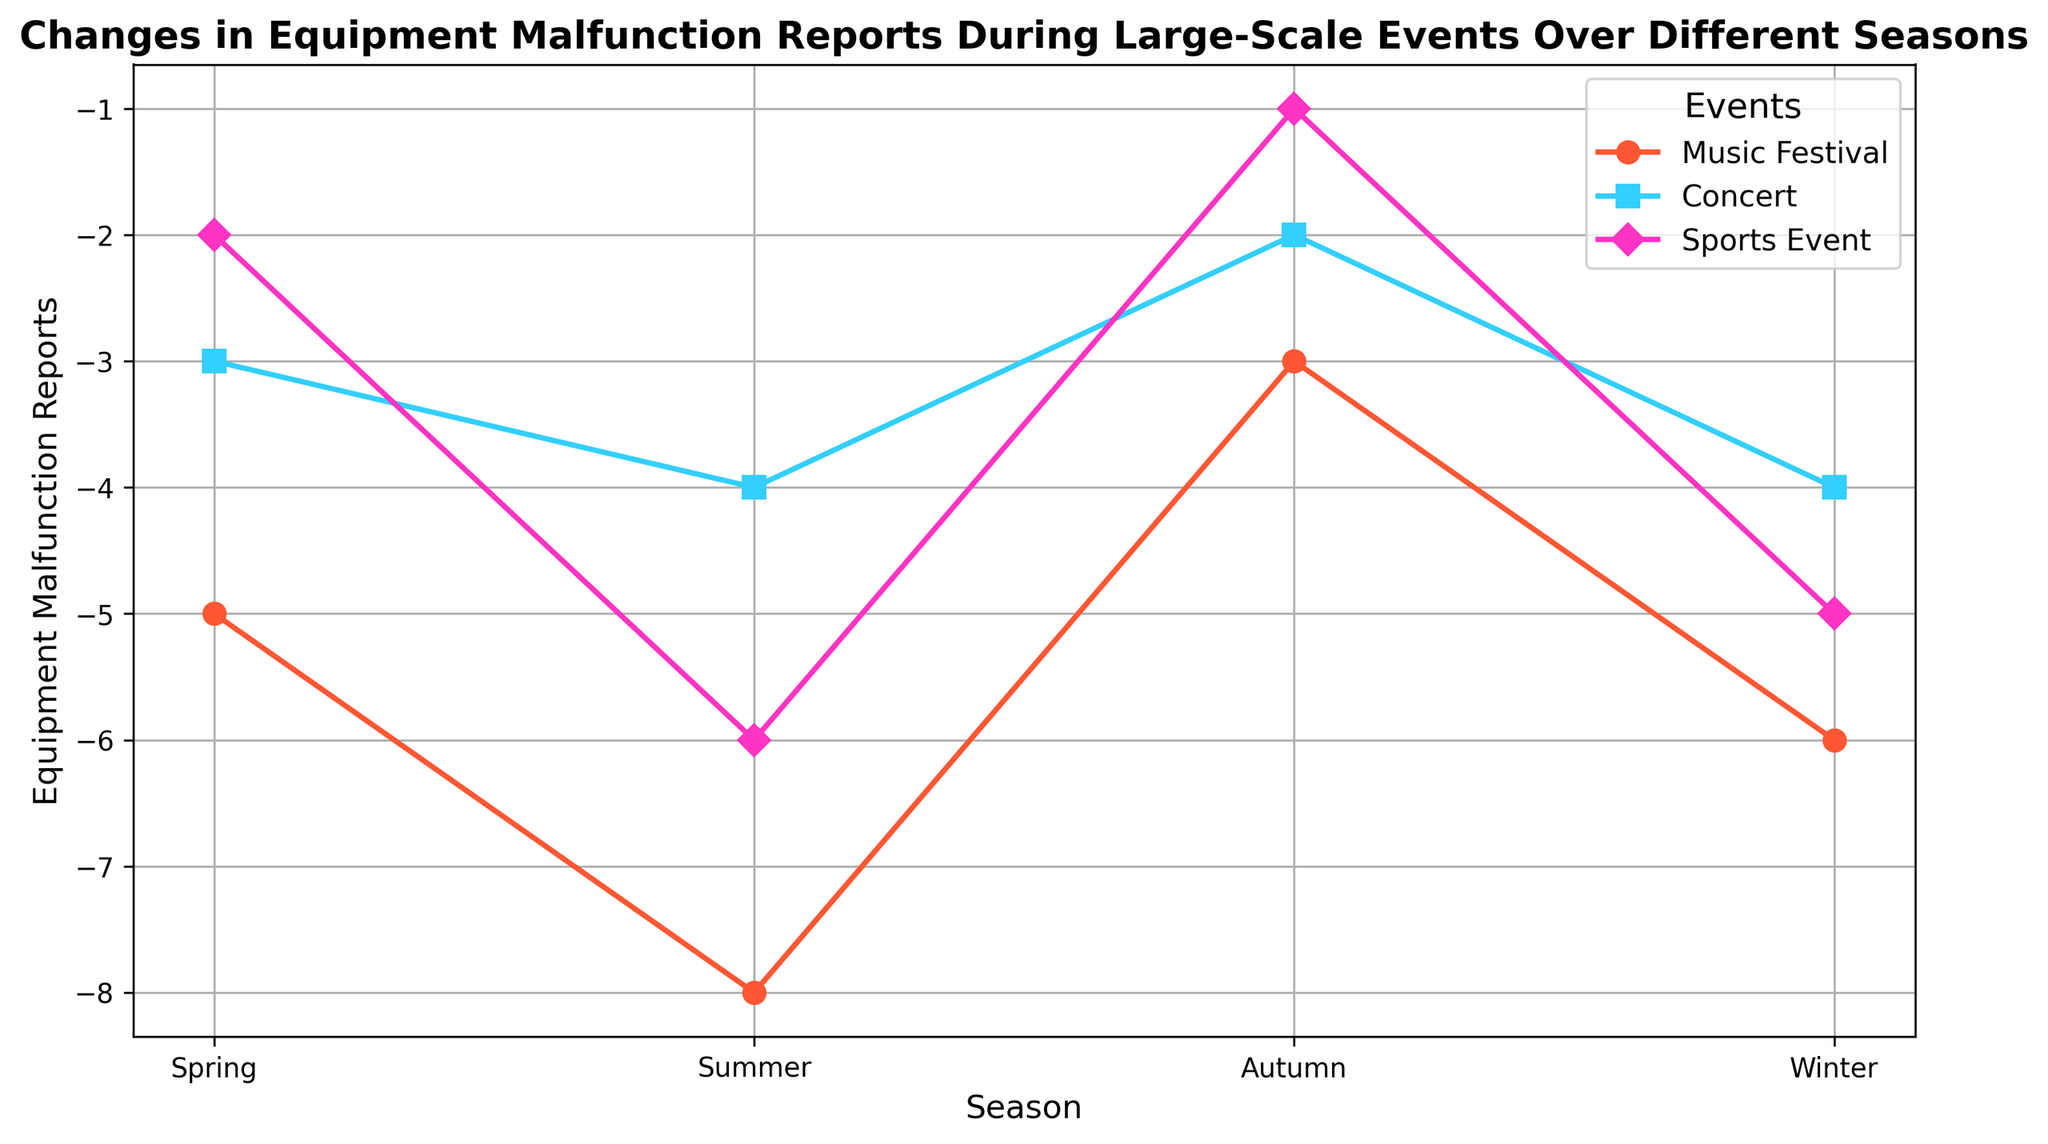What is the comparison of Equipment Malfunction Reports between Music Festivals and Concerts during Spring? During Spring, Music Festivals have -5 reports and Concerts have -3 reports.
Answer: Music Festivals have 2 more reports than Concerts in Spring How many Equipment Malfunction Reports were recorded in total for Sports Events across all seasons? Summing the reports: Spring (-2) + Summer (-6) + Autumn (-1) + Winter (-5) = -14.
Answer: -14 What season had the highest number of Equipment Malfunction Reports for Concerts? The highest value corresponds to the least negative number. Comparing Concerts in Spring (-3), Summer (-4), Autumn (-2), and Winter (-4), Autumn has the maximum value of -2.
Answer: Autumn During which season did Music Festivals experience the highest reports of Equipment Malfunctions, and what was the amount? The highest value corresponds to the least negative number. Comparing Music Festivals in Spring (-5), Summer (-8), Autumn (-3), and Winter (-6), Autumn has the minimum value of -3.
Answer: Autumn, -3 How do the Equipment Malfunction Reports for Summer Music Festivals compare to Winter Music Festivals? Summer Music Festivals had -8 reports, while Winter had -6. Comparing the numbers, Summer had 2 more reports.
Answer: Summer Music Festivals had 2 more reports than Winter Music Festivals What is the average number of Equipment Malfunction Reports for Concerts across all seasons? To find the average for Concerts: Sum the values Spring (-3) + Summer (-4) + Autumn (-2) + Winter (-4) = -13. Divide by 4 (number of seasons): -13 / 4 = -3.25.
Answer: -3.25 Which event had the least Equipment Malfunction Reports in Winter, and what is the amount? Comparing reports for Winter: Music Festival (-6), Concert (-4), Sports Event (-5). Concert has -4, the least among the three.
Answer: Concert, -4 What is the decline in Equipment Malfunction Reports for Sports Events from Spring to Summer? Difference between Sports Events reports: Spring (-2) and Summer (-6) = -6 - (-2) = -4.
Answer: 4 What trend do you observe for Music Festivals' Equipment Malfunction Reports from Spring to Winter? Music Festivals start at -5 in Spring, drop to -8 in Summer, then -3 in Autumn, and finally -6 in Winter, indicating fluctuation with an initial drop, rise and slight fall.
Answer: Fluctuation: drop, rise, slight fall Between Summer and Autumn, how did the Equipment Malfunction Reports change for Concerts? Concerts have -4 reports in Summer and -2 in Autumn. The change is -2 - (-4) = 2.
Answer: Reports decreased by 2 